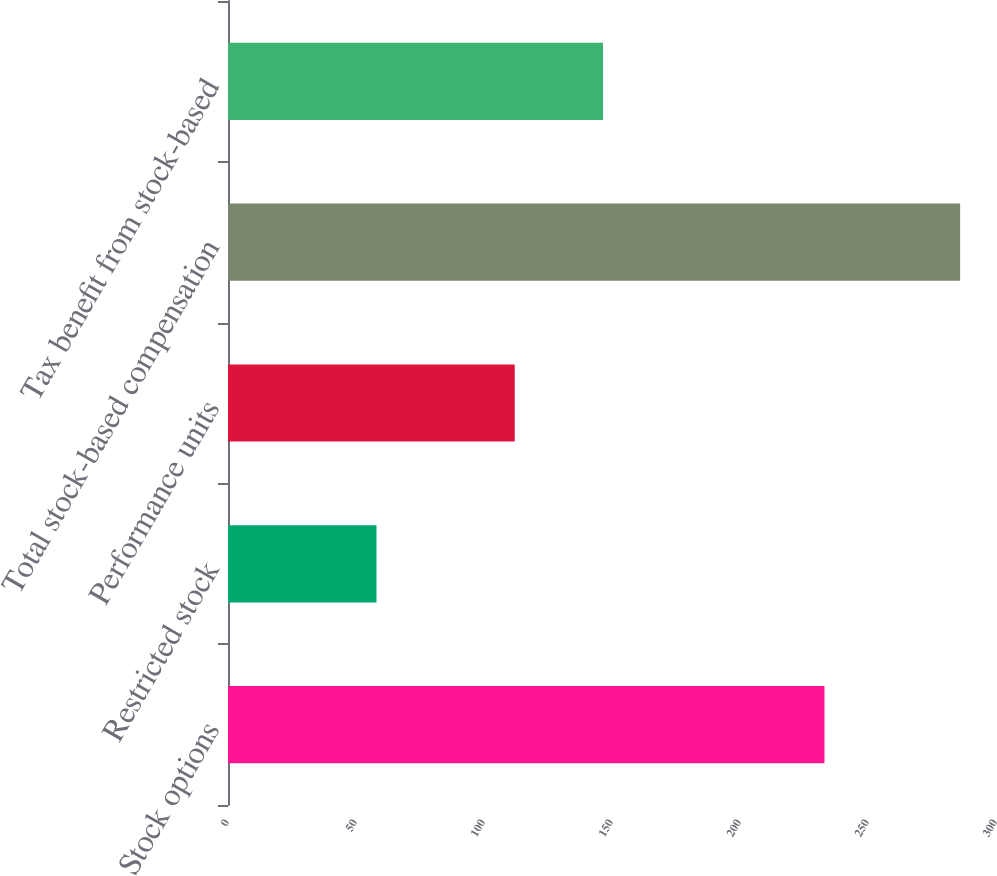Convert chart to OTSL. <chart><loc_0><loc_0><loc_500><loc_500><bar_chart><fcel>Stock options<fcel>Restricted stock<fcel>Performance units<fcel>Total stock-based compensation<fcel>Tax benefit from stock-based<nl><fcel>233<fcel>58<fcel>112<fcel>286<fcel>146.5<nl></chart> 